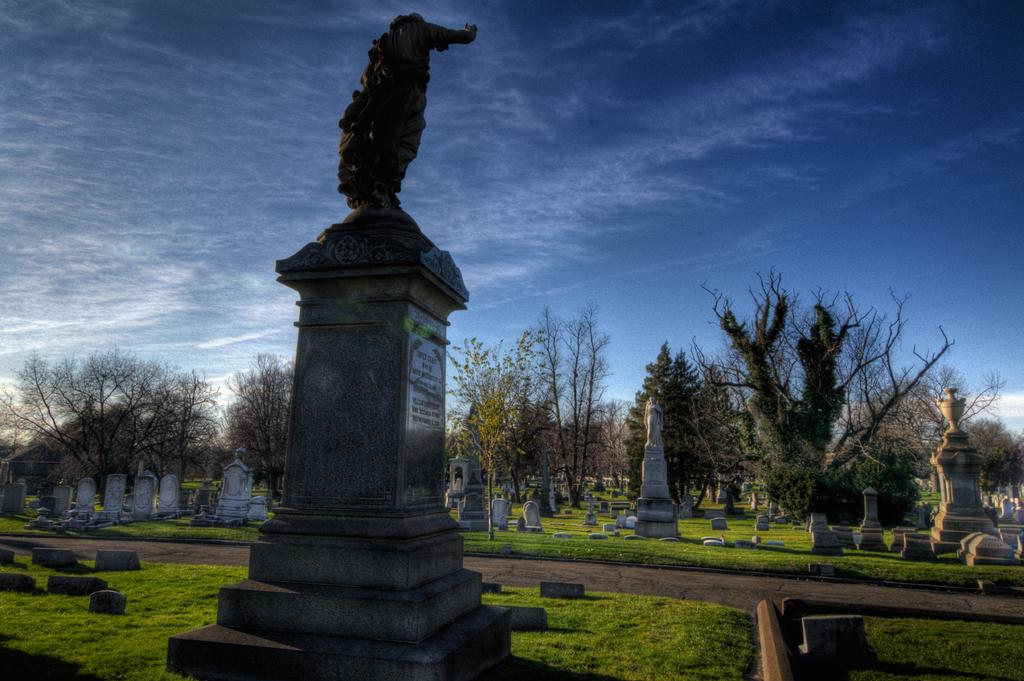What type of structures can be seen in the image? There are graves and statues in the image. What can be seen in the background of the image? There are trees in the background of the image. What is visible at the bottom of the image? The ground is visible at the bottom of the image. What is visible at the top of the image? The sky is visible at the top of the image. What type of music can be heard coming from the graves in the image? There is no music present in the image; it is a visual representation of graves and statues. 